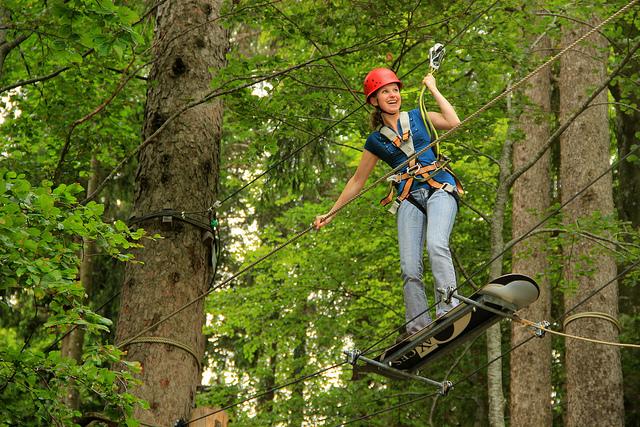Is she working or playing?
Keep it brief. Playing. Is this person wearing safety equipment?
Give a very brief answer. Yes. Does she appear to be happy?
Keep it brief. Yes. 